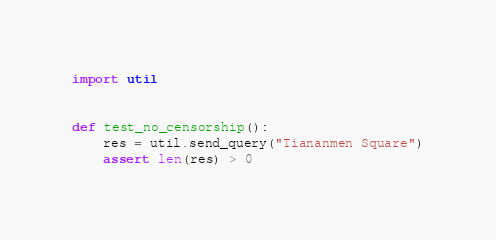<code> <loc_0><loc_0><loc_500><loc_500><_Python_>import util


def test_no_censorship():
    res = util.send_query("Tiananmen Square")
    assert len(res) > 0
</code> 